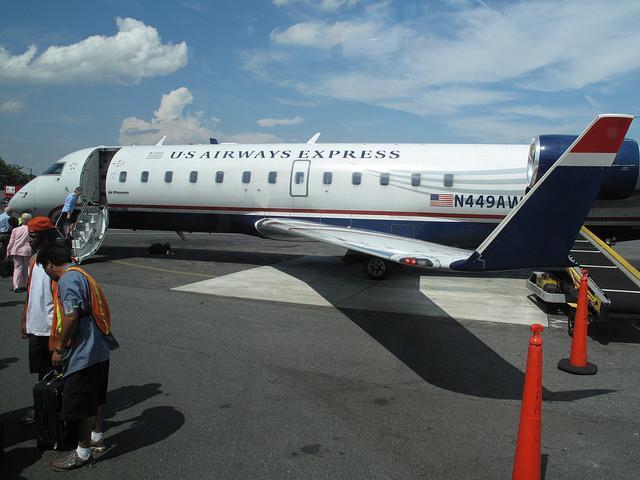How many people are wearing orange vests?
Give a very brief answer. 2. How many planes are in the picture?
Give a very brief answer. 1. How many full cones are viewable?
Give a very brief answer. 2. How many passengers are currently leaving the plane?
Give a very brief answer. 0. How many cones are in the picture?
Give a very brief answer. 2. How many people are there?
Give a very brief answer. 2. 